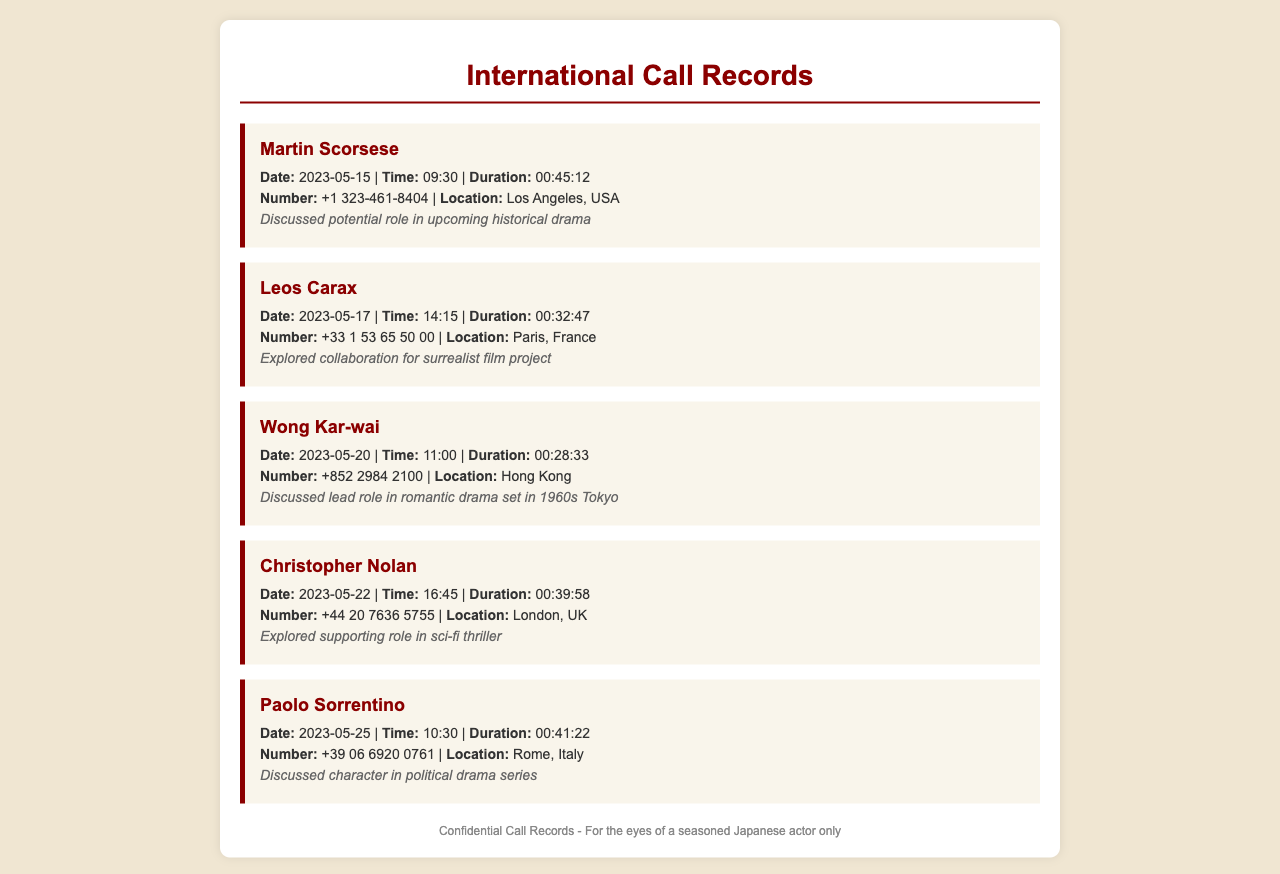what is the location of Martin Scorsese? The document states that the call to Martin Scorsese was made to Los Angeles, USA.
Answer: Los Angeles, USA what was the duration of the call with Wong Kar-wai? The call duration with Wong Kar-wai is noted as 00:28:33.
Answer: 00:28:33 when did the call with Christopher Nolan take place? The document lists the date of the call with Christopher Nolan as 2023-05-22.
Answer: 2023-05-22 who was discussed for a role in a historical drama? Martin Scorsese was discussed for a potential role in an upcoming historical drama.
Answer: Martin Scorsese which director was associated with a political drama series? The call with Paolo Sorrentino involved discussing a character in a political drama series.
Answer: Paolo Sorrentino what is the common theme found in the calls? The calls involve discussions about potential collaborations on various film projects.
Answer: Film projects how many calls were made to directors from Europe? Calls were made to directors from France, Italy, and the UK, totaling three calls.
Answer: Three which call had the longest duration? The call with Paolo Sorrentino had the longest duration of 00:41:22.
Answer: 00:41:22 